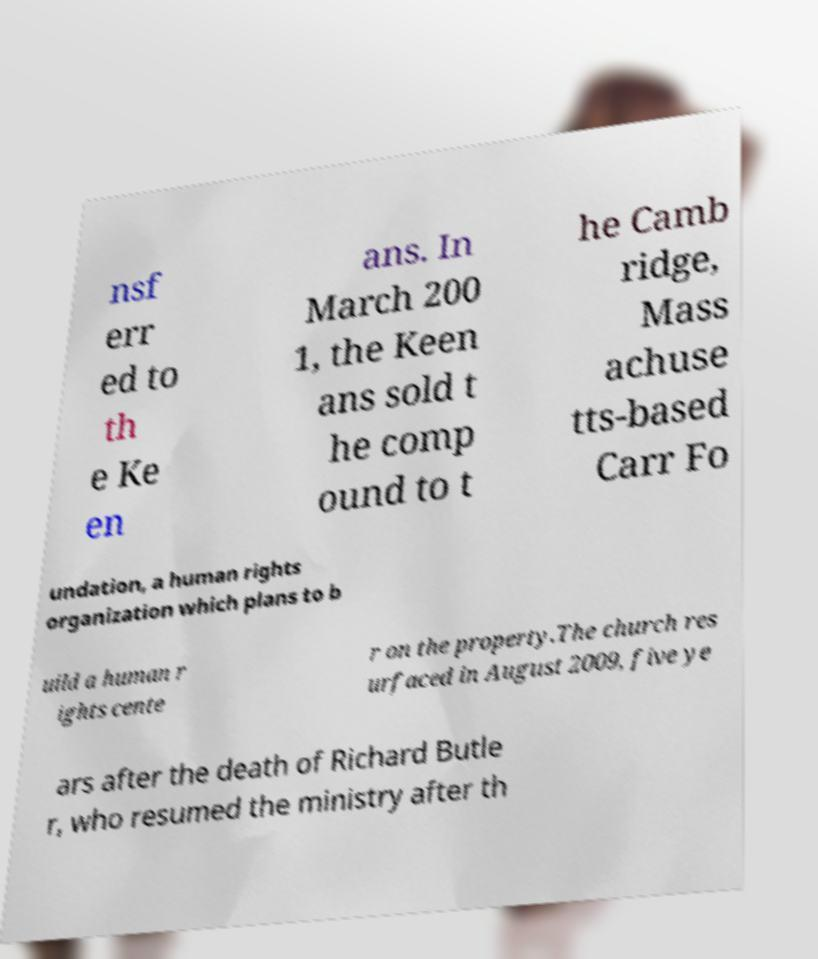Can you accurately transcribe the text from the provided image for me? nsf err ed to th e Ke en ans. In March 200 1, the Keen ans sold t he comp ound to t he Camb ridge, Mass achuse tts-based Carr Fo undation, a human rights organization which plans to b uild a human r ights cente r on the property.The church res urfaced in August 2009, five ye ars after the death of Richard Butle r, who resumed the ministry after th 